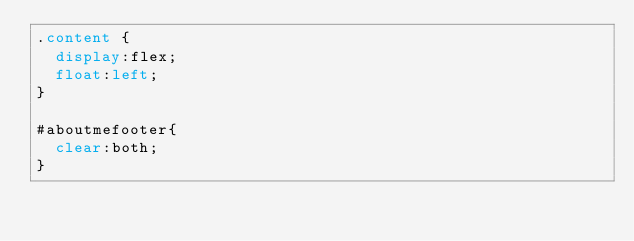<code> <loc_0><loc_0><loc_500><loc_500><_CSS_>.content {
  display:flex;
  float:left;
}

#aboutmefooter{
  clear:both;
}
</code> 